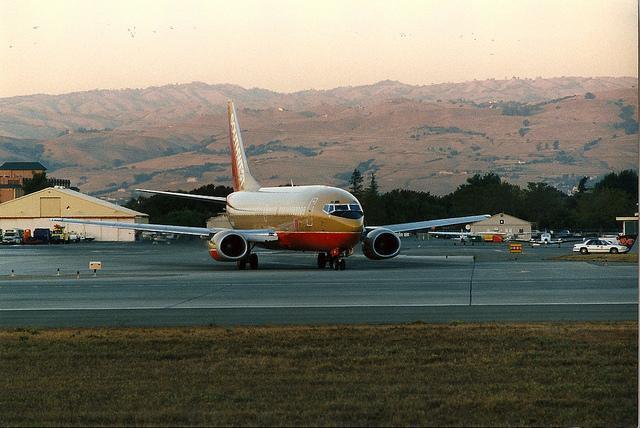How many skateboards are there?
Give a very brief answer. 0. 